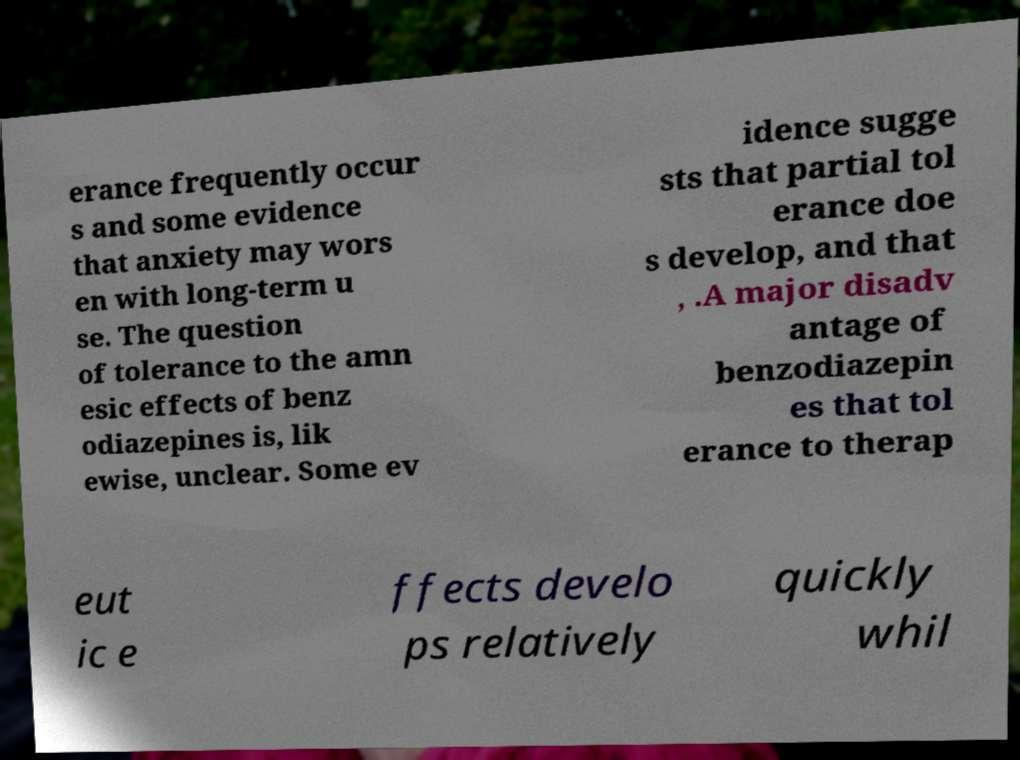I need the written content from this picture converted into text. Can you do that? erance frequently occur s and some evidence that anxiety may wors en with long-term u se. The question of tolerance to the amn esic effects of benz odiazepines is, lik ewise, unclear. Some ev idence sugge sts that partial tol erance doe s develop, and that , .A major disadv antage of benzodiazepin es that tol erance to therap eut ic e ffects develo ps relatively quickly whil 